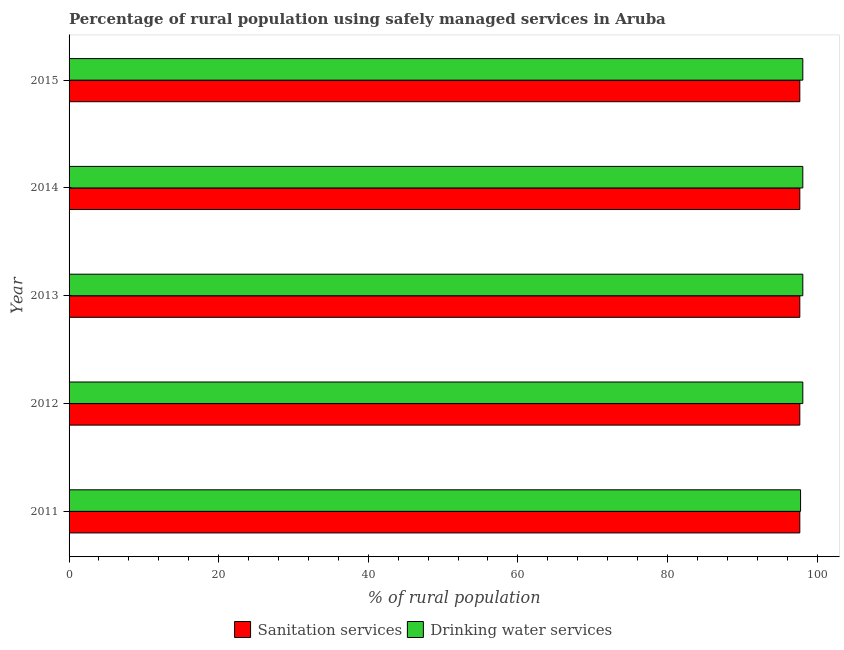Are the number of bars per tick equal to the number of legend labels?
Make the answer very short. Yes. How many bars are there on the 3rd tick from the bottom?
Make the answer very short. 2. What is the label of the 1st group of bars from the top?
Keep it short and to the point. 2015. In how many cases, is the number of bars for a given year not equal to the number of legend labels?
Keep it short and to the point. 0. What is the percentage of rural population who used drinking water services in 2014?
Offer a very short reply. 98.1. Across all years, what is the maximum percentage of rural population who used sanitation services?
Your response must be concise. 97.7. Across all years, what is the minimum percentage of rural population who used drinking water services?
Your answer should be very brief. 97.8. In which year was the percentage of rural population who used sanitation services minimum?
Your answer should be very brief. 2011. What is the total percentage of rural population who used sanitation services in the graph?
Offer a terse response. 488.5. What is the difference between the percentage of rural population who used drinking water services in 2012 and the percentage of rural population who used sanitation services in 2015?
Provide a succinct answer. 0.4. What is the average percentage of rural population who used drinking water services per year?
Ensure brevity in your answer.  98.04. In the year 2011, what is the difference between the percentage of rural population who used sanitation services and percentage of rural population who used drinking water services?
Ensure brevity in your answer.  -0.1. Is the percentage of rural population who used sanitation services in 2012 less than that in 2013?
Your answer should be compact. No. In how many years, is the percentage of rural population who used sanitation services greater than the average percentage of rural population who used sanitation services taken over all years?
Keep it short and to the point. 0. Is the sum of the percentage of rural population who used drinking water services in 2013 and 2015 greater than the maximum percentage of rural population who used sanitation services across all years?
Keep it short and to the point. Yes. What does the 1st bar from the top in 2012 represents?
Keep it short and to the point. Drinking water services. What does the 2nd bar from the bottom in 2012 represents?
Your answer should be very brief. Drinking water services. What is the difference between two consecutive major ticks on the X-axis?
Your answer should be very brief. 20. Are the values on the major ticks of X-axis written in scientific E-notation?
Provide a succinct answer. No. Does the graph contain grids?
Your response must be concise. No. How are the legend labels stacked?
Offer a very short reply. Horizontal. What is the title of the graph?
Offer a terse response. Percentage of rural population using safely managed services in Aruba. What is the label or title of the X-axis?
Ensure brevity in your answer.  % of rural population. What is the % of rural population of Sanitation services in 2011?
Make the answer very short. 97.7. What is the % of rural population of Drinking water services in 2011?
Provide a short and direct response. 97.8. What is the % of rural population of Sanitation services in 2012?
Provide a succinct answer. 97.7. What is the % of rural population in Drinking water services in 2012?
Make the answer very short. 98.1. What is the % of rural population in Sanitation services in 2013?
Provide a succinct answer. 97.7. What is the % of rural population in Drinking water services in 2013?
Your response must be concise. 98.1. What is the % of rural population in Sanitation services in 2014?
Make the answer very short. 97.7. What is the % of rural population of Drinking water services in 2014?
Offer a terse response. 98.1. What is the % of rural population in Sanitation services in 2015?
Your answer should be very brief. 97.7. What is the % of rural population in Drinking water services in 2015?
Provide a short and direct response. 98.1. Across all years, what is the maximum % of rural population of Sanitation services?
Offer a terse response. 97.7. Across all years, what is the maximum % of rural population of Drinking water services?
Keep it short and to the point. 98.1. Across all years, what is the minimum % of rural population in Sanitation services?
Make the answer very short. 97.7. Across all years, what is the minimum % of rural population of Drinking water services?
Give a very brief answer. 97.8. What is the total % of rural population in Sanitation services in the graph?
Make the answer very short. 488.5. What is the total % of rural population of Drinking water services in the graph?
Your answer should be compact. 490.2. What is the difference between the % of rural population in Sanitation services in 2011 and that in 2012?
Your answer should be compact. 0. What is the difference between the % of rural population in Sanitation services in 2011 and that in 2013?
Make the answer very short. 0. What is the difference between the % of rural population of Drinking water services in 2011 and that in 2014?
Provide a short and direct response. -0.3. What is the difference between the % of rural population in Sanitation services in 2011 and that in 2015?
Provide a succinct answer. 0. What is the difference between the % of rural population of Sanitation services in 2012 and that in 2013?
Your response must be concise. 0. What is the difference between the % of rural population in Sanitation services in 2012 and that in 2014?
Offer a terse response. 0. What is the difference between the % of rural population in Sanitation services in 2012 and that in 2015?
Make the answer very short. 0. What is the difference between the % of rural population in Drinking water services in 2012 and that in 2015?
Make the answer very short. 0. What is the difference between the % of rural population in Drinking water services in 2013 and that in 2014?
Give a very brief answer. 0. What is the difference between the % of rural population in Sanitation services in 2013 and that in 2015?
Offer a very short reply. 0. What is the difference between the % of rural population of Drinking water services in 2014 and that in 2015?
Provide a short and direct response. 0. What is the difference between the % of rural population of Sanitation services in 2011 and the % of rural population of Drinking water services in 2012?
Offer a terse response. -0.4. What is the difference between the % of rural population in Sanitation services in 2011 and the % of rural population in Drinking water services in 2014?
Keep it short and to the point. -0.4. What is the difference between the % of rural population of Sanitation services in 2011 and the % of rural population of Drinking water services in 2015?
Offer a terse response. -0.4. What is the difference between the % of rural population of Sanitation services in 2012 and the % of rural population of Drinking water services in 2013?
Ensure brevity in your answer.  -0.4. What is the difference between the % of rural population in Sanitation services in 2012 and the % of rural population in Drinking water services in 2015?
Provide a short and direct response. -0.4. What is the difference between the % of rural population in Sanitation services in 2013 and the % of rural population in Drinking water services in 2014?
Offer a terse response. -0.4. What is the difference between the % of rural population in Sanitation services in 2014 and the % of rural population in Drinking water services in 2015?
Keep it short and to the point. -0.4. What is the average % of rural population in Sanitation services per year?
Your response must be concise. 97.7. What is the average % of rural population of Drinking water services per year?
Offer a terse response. 98.04. In the year 2012, what is the difference between the % of rural population in Sanitation services and % of rural population in Drinking water services?
Make the answer very short. -0.4. In the year 2014, what is the difference between the % of rural population of Sanitation services and % of rural population of Drinking water services?
Offer a very short reply. -0.4. What is the ratio of the % of rural population of Sanitation services in 2011 to that in 2012?
Give a very brief answer. 1. What is the ratio of the % of rural population of Drinking water services in 2011 to that in 2012?
Give a very brief answer. 1. What is the ratio of the % of rural population in Sanitation services in 2011 to that in 2013?
Your answer should be compact. 1. What is the ratio of the % of rural population of Drinking water services in 2011 to that in 2013?
Keep it short and to the point. 1. What is the ratio of the % of rural population of Sanitation services in 2011 to that in 2014?
Offer a very short reply. 1. What is the ratio of the % of rural population in Drinking water services in 2011 to that in 2015?
Ensure brevity in your answer.  1. What is the ratio of the % of rural population of Drinking water services in 2012 to that in 2013?
Your answer should be compact. 1. What is the ratio of the % of rural population of Drinking water services in 2012 to that in 2014?
Give a very brief answer. 1. What is the ratio of the % of rural population of Sanitation services in 2013 to that in 2014?
Provide a succinct answer. 1. What is the ratio of the % of rural population in Drinking water services in 2013 to that in 2014?
Your response must be concise. 1. What is the ratio of the % of rural population of Drinking water services in 2014 to that in 2015?
Make the answer very short. 1. What is the difference between the highest and the second highest % of rural population in Sanitation services?
Offer a very short reply. 0. What is the difference between the highest and the lowest % of rural population of Sanitation services?
Provide a short and direct response. 0. 